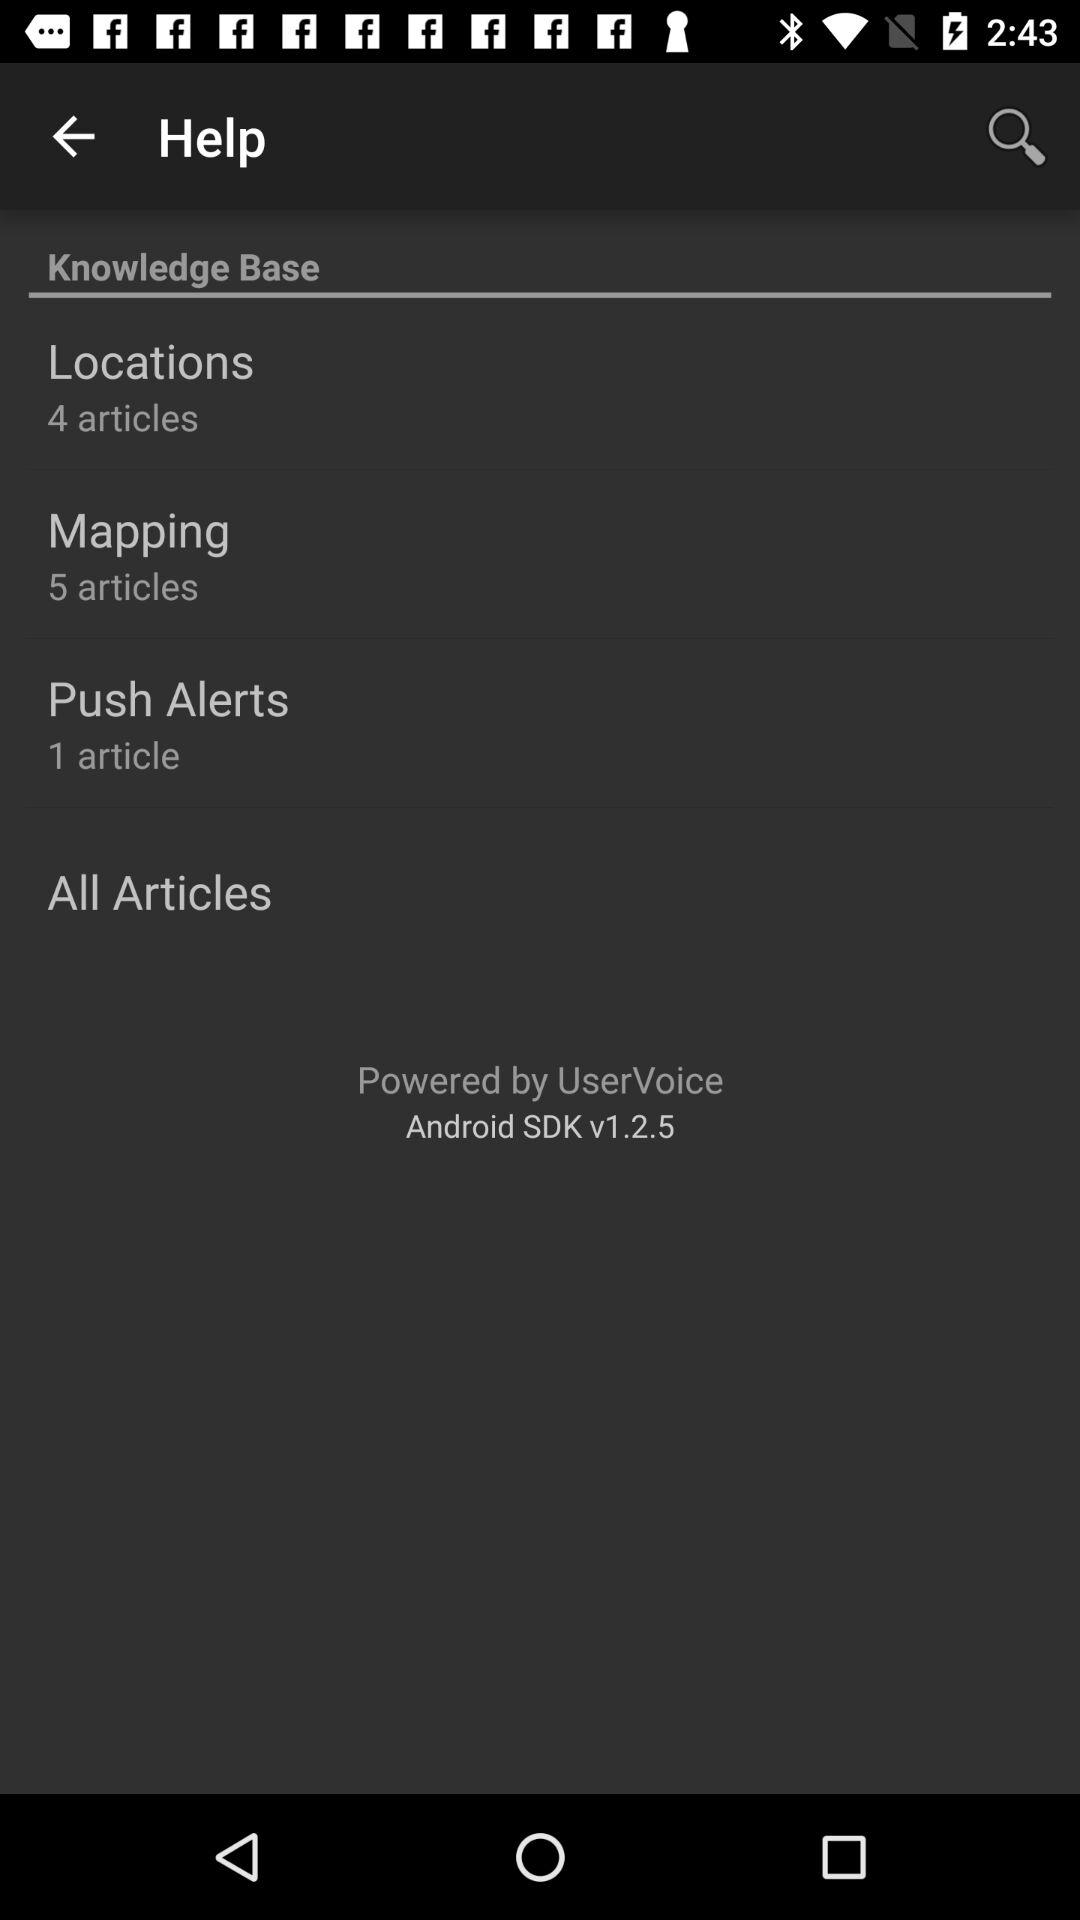What is the android SDK?
When the provided information is insufficient, respond with <no answer>. <no answer> 